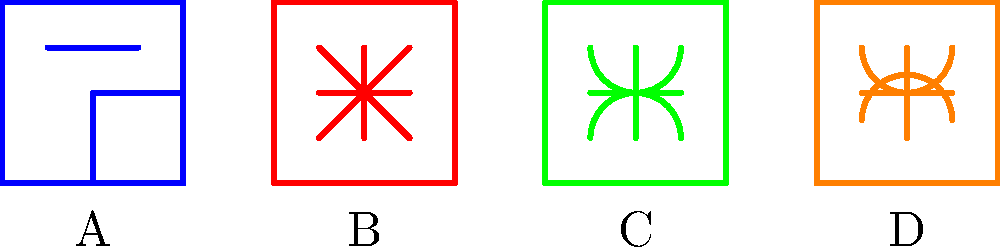As a sailor, you frequently use various knots for different purposes. Identify the knot labeled 'B' in the diagram, which is commonly used for creating a fixed loop at the end of a rope. To identify the knot labeled 'B', let's examine the characteristics of each knot in the diagram:

1. Knot A: This knot has a distinctive loop and is commonly known as the Bowline knot.

2. Knot B: This knot resembles the number 8, with two loops crossing over each other. This is the Figure-8 knot.

3. Knot C: This knot shows two turns around a central point, which is characteristic of the Clove Hitch.

4. Knot D: This knot displays two turns around a standing part of the rope, typical of Two Half Hitches.

The question asks for the knot that creates a fixed loop at the end of a rope. Among these knots, the Figure-8 knot (Knot B) is known for this purpose. It creates a strong, non-slip loop that maintains its shape under load, making it ideal for various sailing applications where a secure fixed loop is needed.
Answer: Figure-8 knot 